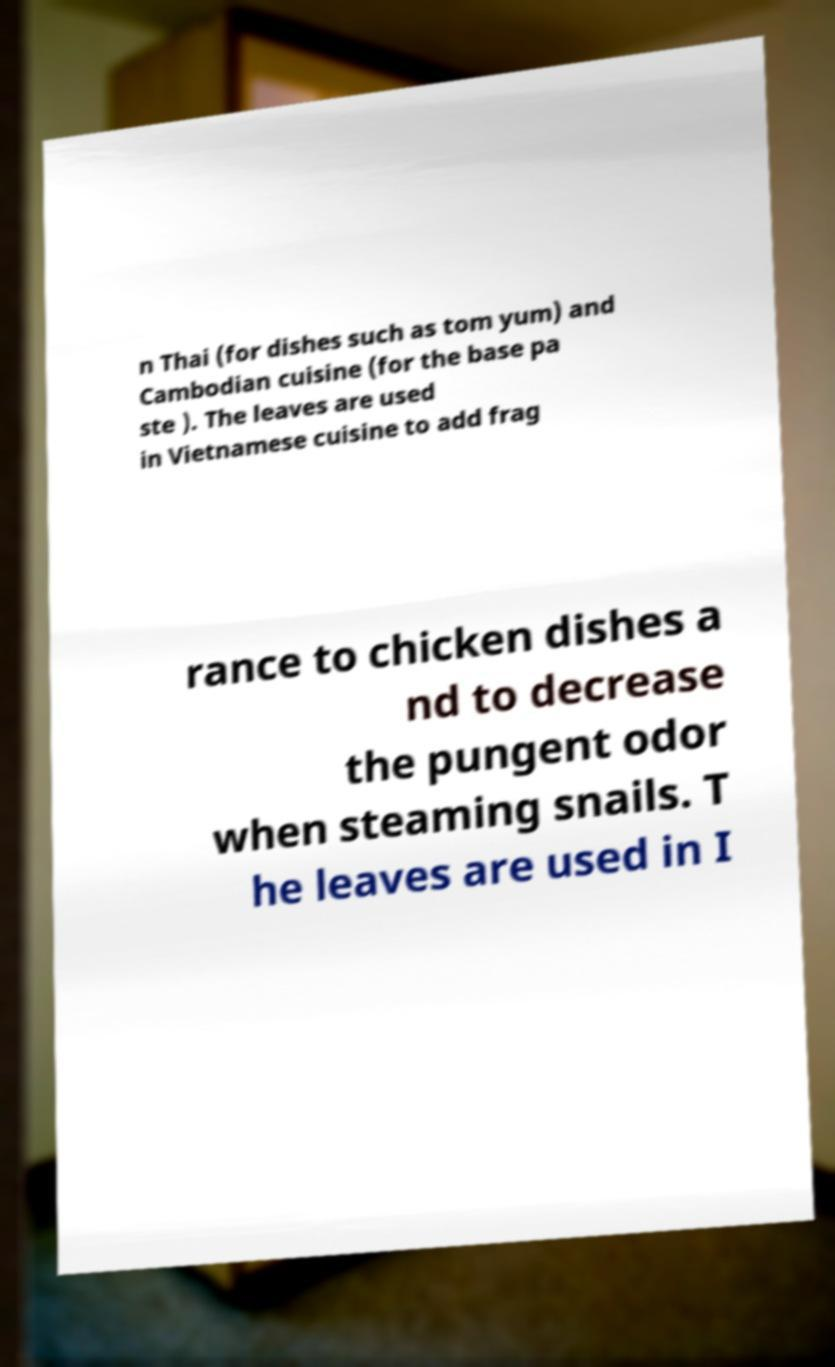Can you read and provide the text displayed in the image?This photo seems to have some interesting text. Can you extract and type it out for me? n Thai (for dishes such as tom yum) and Cambodian cuisine (for the base pa ste ). The leaves are used in Vietnamese cuisine to add frag rance to chicken dishes a nd to decrease the pungent odor when steaming snails. T he leaves are used in I 